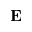<formula> <loc_0><loc_0><loc_500><loc_500>E</formula> 